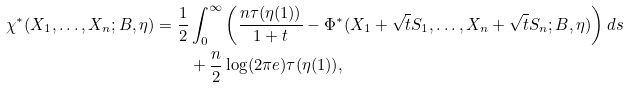<formula> <loc_0><loc_0><loc_500><loc_500>\chi ^ { * } ( X _ { 1 } , \dots , X _ { n } ; B , \eta ) = \frac { 1 } { 2 } & \int _ { 0 } ^ { \infty } \left ( \frac { n \tau ( \eta ( 1 ) ) } { 1 + t } - \Phi ^ { * } ( X _ { 1 } + \sqrt { t } S _ { 1 } , \dots , X _ { n } + \sqrt { t } S _ { n } ; B , \eta ) \right ) d s \\ & + \frac { n } { 2 } \log ( 2 \pi e ) \tau ( \eta ( 1 ) ) ,</formula> 